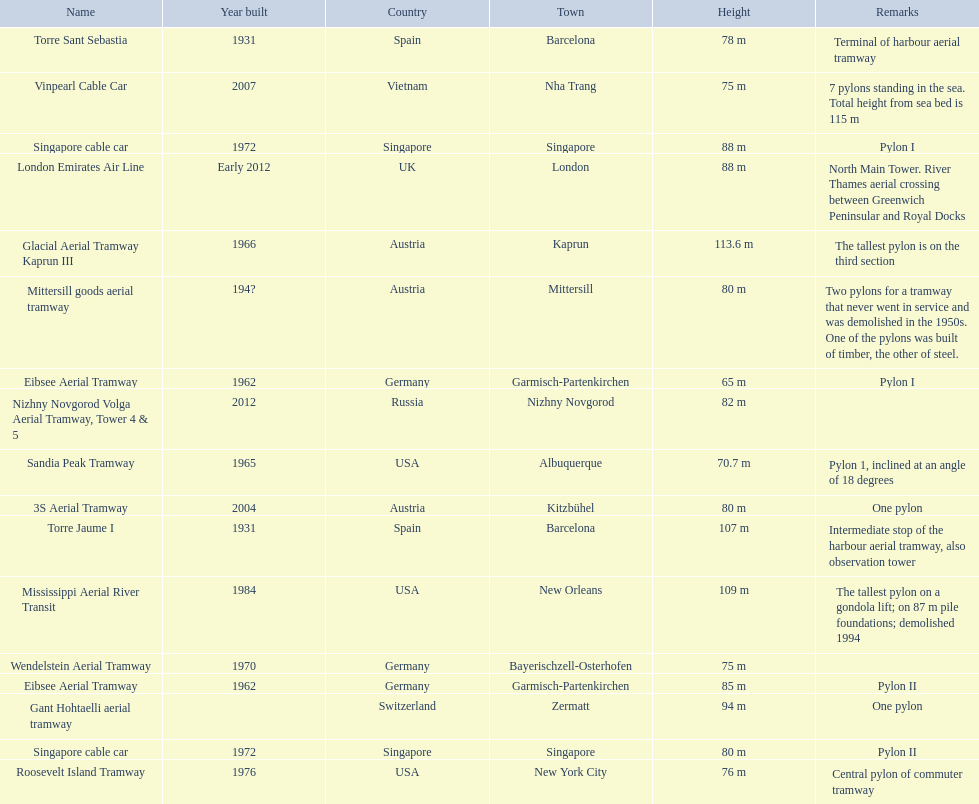How many aerial lift pylon's on the list are located in the usa? Mississippi Aerial River Transit, Roosevelt Island Tramway, Sandia Peak Tramway. Of the pylon's located in the usa how many were built after 1970? Mississippi Aerial River Transit, Roosevelt Island Tramway. Of the pylon's built after 1970 which is the tallest pylon on a gondola lift? Mississippi Aerial River Transit. How many meters is the tallest pylon on a gondola lift? 109 m. 